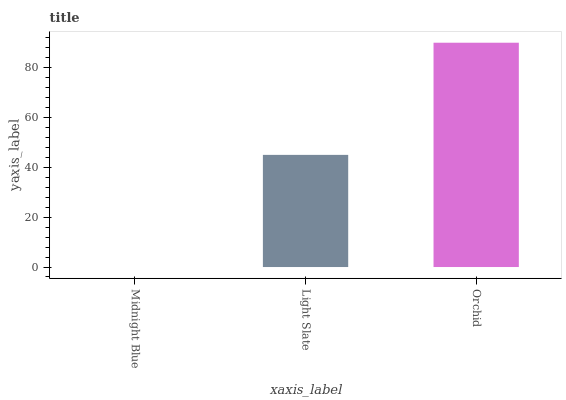Is Midnight Blue the minimum?
Answer yes or no. Yes. Is Orchid the maximum?
Answer yes or no. Yes. Is Light Slate the minimum?
Answer yes or no. No. Is Light Slate the maximum?
Answer yes or no. No. Is Light Slate greater than Midnight Blue?
Answer yes or no. Yes. Is Midnight Blue less than Light Slate?
Answer yes or no. Yes. Is Midnight Blue greater than Light Slate?
Answer yes or no. No. Is Light Slate less than Midnight Blue?
Answer yes or no. No. Is Light Slate the high median?
Answer yes or no. Yes. Is Light Slate the low median?
Answer yes or no. Yes. Is Midnight Blue the high median?
Answer yes or no. No. Is Midnight Blue the low median?
Answer yes or no. No. 